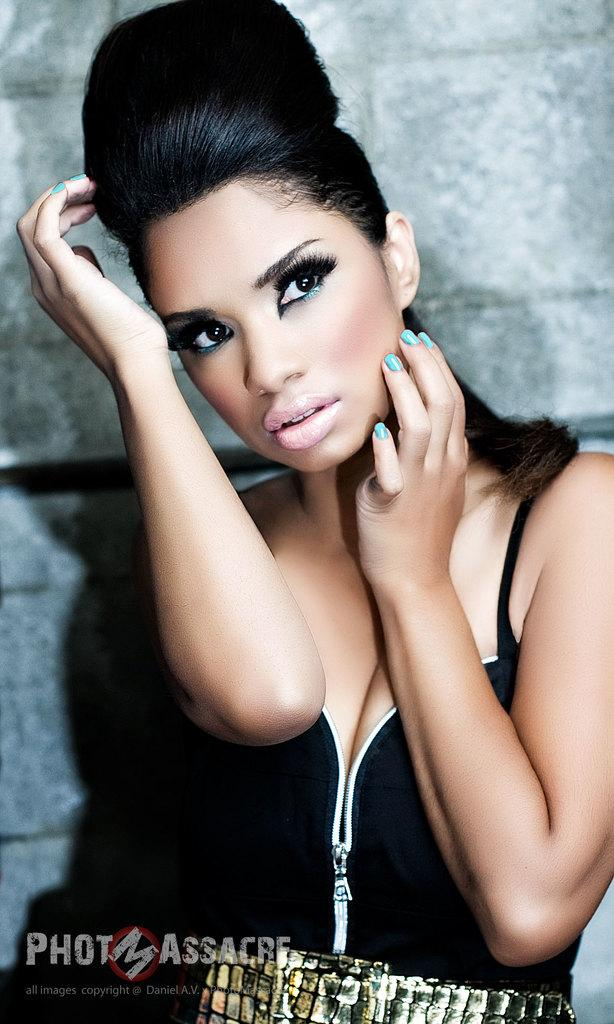What is the main subject of the image? There is a woman standing in the image. Is there any text present in the image? Yes, there is text at the bottom left corner of the image. What can be seen in the background of the image? There is a wall visible in the background of the image. What type of crack can be seen on the wall in the image? There is no crack visible on the wall in the image. What kind of industry is depicted in the image? There is no industry depicted in the image; it features a woman standing and text in the corner. 